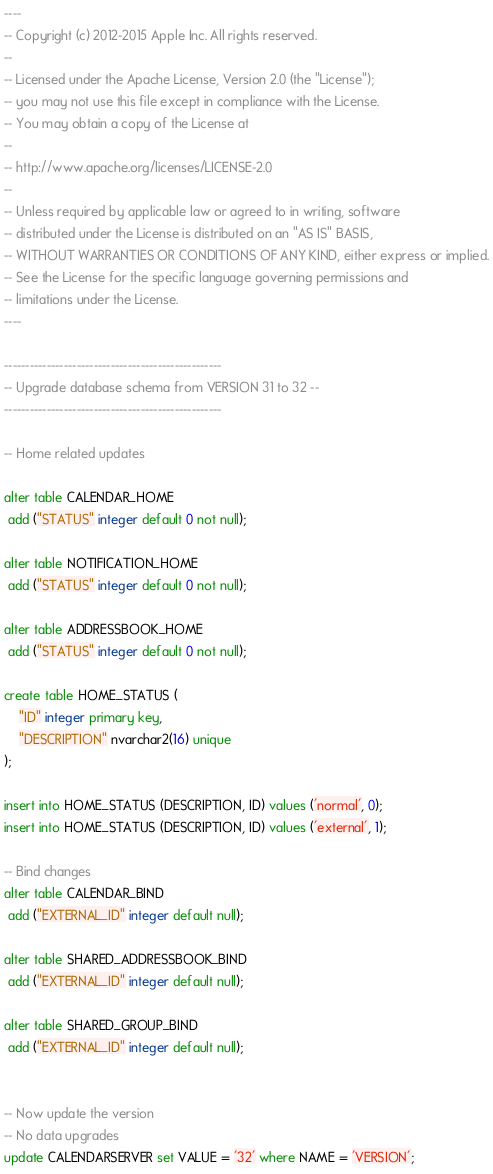Convert code to text. <code><loc_0><loc_0><loc_500><loc_500><_SQL_>----
-- Copyright (c) 2012-2015 Apple Inc. All rights reserved.
--
-- Licensed under the Apache License, Version 2.0 (the "License");
-- you may not use this file except in compliance with the License.
-- You may obtain a copy of the License at
--
-- http://www.apache.org/licenses/LICENSE-2.0
--
-- Unless required by applicable law or agreed to in writing, software
-- distributed under the License is distributed on an "AS IS" BASIS,
-- WITHOUT WARRANTIES OR CONDITIONS OF ANY KIND, either express or implied.
-- See the License for the specific language governing permissions and
-- limitations under the License.
----

---------------------------------------------------
-- Upgrade database schema from VERSION 31 to 32 --
---------------------------------------------------

-- Home related updates

alter table CALENDAR_HOME
 add ("STATUS" integer default 0 not null);

alter table NOTIFICATION_HOME
 add ("STATUS" integer default 0 not null);

alter table ADDRESSBOOK_HOME
 add ("STATUS" integer default 0 not null);

create table HOME_STATUS (
    "ID" integer primary key,
    "DESCRIPTION" nvarchar2(16) unique
);

insert into HOME_STATUS (DESCRIPTION, ID) values ('normal', 0);
insert into HOME_STATUS (DESCRIPTION, ID) values ('external', 1);

-- Bind changes
alter table CALENDAR_BIND
 add ("EXTERNAL_ID" integer default null);

alter table SHARED_ADDRESSBOOK_BIND
 add ("EXTERNAL_ID" integer default null);

alter table SHARED_GROUP_BIND
 add ("EXTERNAL_ID" integer default null);


-- Now update the version
-- No data upgrades
update CALENDARSERVER set VALUE = '32' where NAME = 'VERSION';
</code> 